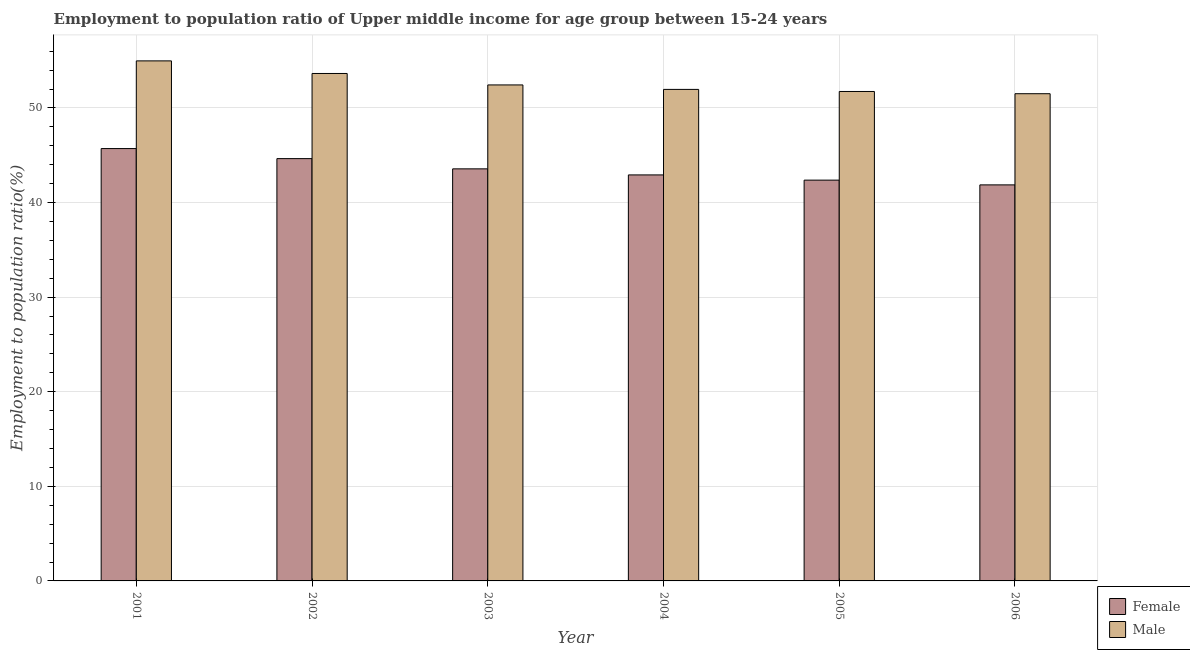How many different coloured bars are there?
Offer a very short reply. 2. Are the number of bars on each tick of the X-axis equal?
Your answer should be very brief. Yes. What is the employment to population ratio(male) in 2005?
Keep it short and to the point. 51.74. Across all years, what is the maximum employment to population ratio(male)?
Your answer should be very brief. 54.98. Across all years, what is the minimum employment to population ratio(female)?
Make the answer very short. 41.87. In which year was the employment to population ratio(male) maximum?
Make the answer very short. 2001. In which year was the employment to population ratio(male) minimum?
Your response must be concise. 2006. What is the total employment to population ratio(male) in the graph?
Provide a short and direct response. 316.27. What is the difference between the employment to population ratio(female) in 2003 and that in 2005?
Offer a terse response. 1.19. What is the difference between the employment to population ratio(male) in 2005 and the employment to population ratio(female) in 2001?
Keep it short and to the point. -3.24. What is the average employment to population ratio(male) per year?
Give a very brief answer. 52.71. What is the ratio of the employment to population ratio(male) in 2002 to that in 2005?
Provide a succinct answer. 1.04. What is the difference between the highest and the second highest employment to population ratio(female)?
Your answer should be very brief. 1.06. What is the difference between the highest and the lowest employment to population ratio(male)?
Provide a short and direct response. 3.47. What does the 1st bar from the right in 2005 represents?
Offer a terse response. Male. How many bars are there?
Offer a very short reply. 12. Are all the bars in the graph horizontal?
Keep it short and to the point. No. How many years are there in the graph?
Your answer should be very brief. 6. What is the difference between two consecutive major ticks on the Y-axis?
Your response must be concise. 10. Does the graph contain grids?
Your response must be concise. Yes. Where does the legend appear in the graph?
Your answer should be compact. Bottom right. How many legend labels are there?
Provide a short and direct response. 2. What is the title of the graph?
Provide a short and direct response. Employment to population ratio of Upper middle income for age group between 15-24 years. What is the label or title of the X-axis?
Provide a succinct answer. Year. What is the label or title of the Y-axis?
Provide a short and direct response. Employment to population ratio(%). What is the Employment to population ratio(%) in Female in 2001?
Keep it short and to the point. 45.71. What is the Employment to population ratio(%) of Male in 2001?
Give a very brief answer. 54.98. What is the Employment to population ratio(%) of Female in 2002?
Your response must be concise. 44.65. What is the Employment to population ratio(%) of Male in 2002?
Keep it short and to the point. 53.65. What is the Employment to population ratio(%) of Female in 2003?
Provide a succinct answer. 43.56. What is the Employment to population ratio(%) of Male in 2003?
Keep it short and to the point. 52.43. What is the Employment to population ratio(%) of Female in 2004?
Your response must be concise. 42.92. What is the Employment to population ratio(%) of Male in 2004?
Provide a succinct answer. 51.96. What is the Employment to population ratio(%) in Female in 2005?
Your answer should be very brief. 42.37. What is the Employment to population ratio(%) in Male in 2005?
Ensure brevity in your answer.  51.74. What is the Employment to population ratio(%) of Female in 2006?
Offer a very short reply. 41.87. What is the Employment to population ratio(%) in Male in 2006?
Provide a succinct answer. 51.51. Across all years, what is the maximum Employment to population ratio(%) in Female?
Your answer should be compact. 45.71. Across all years, what is the maximum Employment to population ratio(%) of Male?
Keep it short and to the point. 54.98. Across all years, what is the minimum Employment to population ratio(%) of Female?
Offer a terse response. 41.87. Across all years, what is the minimum Employment to population ratio(%) in Male?
Make the answer very short. 51.51. What is the total Employment to population ratio(%) in Female in the graph?
Make the answer very short. 261.08. What is the total Employment to population ratio(%) in Male in the graph?
Ensure brevity in your answer.  316.27. What is the difference between the Employment to population ratio(%) in Female in 2001 and that in 2002?
Your answer should be very brief. 1.06. What is the difference between the Employment to population ratio(%) in Male in 2001 and that in 2002?
Make the answer very short. 1.33. What is the difference between the Employment to population ratio(%) of Female in 2001 and that in 2003?
Your answer should be compact. 2.14. What is the difference between the Employment to population ratio(%) of Male in 2001 and that in 2003?
Keep it short and to the point. 2.54. What is the difference between the Employment to population ratio(%) in Female in 2001 and that in 2004?
Ensure brevity in your answer.  2.78. What is the difference between the Employment to population ratio(%) of Male in 2001 and that in 2004?
Give a very brief answer. 3.01. What is the difference between the Employment to population ratio(%) in Female in 2001 and that in 2005?
Offer a terse response. 3.34. What is the difference between the Employment to population ratio(%) in Male in 2001 and that in 2005?
Ensure brevity in your answer.  3.24. What is the difference between the Employment to population ratio(%) of Female in 2001 and that in 2006?
Keep it short and to the point. 3.84. What is the difference between the Employment to population ratio(%) of Male in 2001 and that in 2006?
Keep it short and to the point. 3.47. What is the difference between the Employment to population ratio(%) in Female in 2002 and that in 2003?
Your answer should be very brief. 1.08. What is the difference between the Employment to population ratio(%) of Male in 2002 and that in 2003?
Offer a terse response. 1.21. What is the difference between the Employment to population ratio(%) in Female in 2002 and that in 2004?
Keep it short and to the point. 1.72. What is the difference between the Employment to population ratio(%) in Male in 2002 and that in 2004?
Keep it short and to the point. 1.68. What is the difference between the Employment to population ratio(%) of Female in 2002 and that in 2005?
Ensure brevity in your answer.  2.27. What is the difference between the Employment to population ratio(%) in Male in 2002 and that in 2005?
Your answer should be very brief. 1.9. What is the difference between the Employment to population ratio(%) in Female in 2002 and that in 2006?
Make the answer very short. 2.78. What is the difference between the Employment to population ratio(%) of Male in 2002 and that in 2006?
Offer a very short reply. 2.14. What is the difference between the Employment to population ratio(%) of Female in 2003 and that in 2004?
Provide a short and direct response. 0.64. What is the difference between the Employment to population ratio(%) in Male in 2003 and that in 2004?
Provide a succinct answer. 0.47. What is the difference between the Employment to population ratio(%) of Female in 2003 and that in 2005?
Provide a short and direct response. 1.19. What is the difference between the Employment to population ratio(%) of Male in 2003 and that in 2005?
Your answer should be very brief. 0.69. What is the difference between the Employment to population ratio(%) of Female in 2003 and that in 2006?
Ensure brevity in your answer.  1.69. What is the difference between the Employment to population ratio(%) in Male in 2003 and that in 2006?
Provide a short and direct response. 0.93. What is the difference between the Employment to population ratio(%) of Female in 2004 and that in 2005?
Your answer should be compact. 0.55. What is the difference between the Employment to population ratio(%) in Male in 2004 and that in 2005?
Keep it short and to the point. 0.22. What is the difference between the Employment to population ratio(%) in Female in 2004 and that in 2006?
Ensure brevity in your answer.  1.05. What is the difference between the Employment to population ratio(%) of Male in 2004 and that in 2006?
Ensure brevity in your answer.  0.46. What is the difference between the Employment to population ratio(%) of Female in 2005 and that in 2006?
Provide a succinct answer. 0.5. What is the difference between the Employment to population ratio(%) of Male in 2005 and that in 2006?
Ensure brevity in your answer.  0.24. What is the difference between the Employment to population ratio(%) in Female in 2001 and the Employment to population ratio(%) in Male in 2002?
Give a very brief answer. -7.94. What is the difference between the Employment to population ratio(%) of Female in 2001 and the Employment to population ratio(%) of Male in 2003?
Provide a succinct answer. -6.73. What is the difference between the Employment to population ratio(%) in Female in 2001 and the Employment to population ratio(%) in Male in 2004?
Offer a terse response. -6.26. What is the difference between the Employment to population ratio(%) in Female in 2001 and the Employment to population ratio(%) in Male in 2005?
Provide a succinct answer. -6.03. What is the difference between the Employment to population ratio(%) in Female in 2001 and the Employment to population ratio(%) in Male in 2006?
Your response must be concise. -5.8. What is the difference between the Employment to population ratio(%) in Female in 2002 and the Employment to population ratio(%) in Male in 2003?
Your answer should be very brief. -7.79. What is the difference between the Employment to population ratio(%) of Female in 2002 and the Employment to population ratio(%) of Male in 2004?
Your answer should be very brief. -7.32. What is the difference between the Employment to population ratio(%) in Female in 2002 and the Employment to population ratio(%) in Male in 2005?
Offer a terse response. -7.1. What is the difference between the Employment to population ratio(%) in Female in 2002 and the Employment to population ratio(%) in Male in 2006?
Offer a terse response. -6.86. What is the difference between the Employment to population ratio(%) in Female in 2003 and the Employment to population ratio(%) in Male in 2004?
Your response must be concise. -8.4. What is the difference between the Employment to population ratio(%) in Female in 2003 and the Employment to population ratio(%) in Male in 2005?
Keep it short and to the point. -8.18. What is the difference between the Employment to population ratio(%) of Female in 2003 and the Employment to population ratio(%) of Male in 2006?
Your answer should be compact. -7.94. What is the difference between the Employment to population ratio(%) in Female in 2004 and the Employment to population ratio(%) in Male in 2005?
Your answer should be very brief. -8.82. What is the difference between the Employment to population ratio(%) in Female in 2004 and the Employment to population ratio(%) in Male in 2006?
Your answer should be compact. -8.58. What is the difference between the Employment to population ratio(%) of Female in 2005 and the Employment to population ratio(%) of Male in 2006?
Keep it short and to the point. -9.14. What is the average Employment to population ratio(%) in Female per year?
Offer a very short reply. 43.51. What is the average Employment to population ratio(%) of Male per year?
Your response must be concise. 52.71. In the year 2001, what is the difference between the Employment to population ratio(%) in Female and Employment to population ratio(%) in Male?
Your answer should be very brief. -9.27. In the year 2002, what is the difference between the Employment to population ratio(%) in Female and Employment to population ratio(%) in Male?
Your answer should be compact. -9. In the year 2003, what is the difference between the Employment to population ratio(%) in Female and Employment to population ratio(%) in Male?
Provide a short and direct response. -8.87. In the year 2004, what is the difference between the Employment to population ratio(%) of Female and Employment to population ratio(%) of Male?
Ensure brevity in your answer.  -9.04. In the year 2005, what is the difference between the Employment to population ratio(%) of Female and Employment to population ratio(%) of Male?
Offer a very short reply. -9.37. In the year 2006, what is the difference between the Employment to population ratio(%) of Female and Employment to population ratio(%) of Male?
Make the answer very short. -9.64. What is the ratio of the Employment to population ratio(%) of Female in 2001 to that in 2002?
Your response must be concise. 1.02. What is the ratio of the Employment to population ratio(%) of Male in 2001 to that in 2002?
Your answer should be very brief. 1.02. What is the ratio of the Employment to population ratio(%) in Female in 2001 to that in 2003?
Your answer should be compact. 1.05. What is the ratio of the Employment to population ratio(%) in Male in 2001 to that in 2003?
Your response must be concise. 1.05. What is the ratio of the Employment to population ratio(%) of Female in 2001 to that in 2004?
Keep it short and to the point. 1.06. What is the ratio of the Employment to population ratio(%) of Male in 2001 to that in 2004?
Provide a short and direct response. 1.06. What is the ratio of the Employment to population ratio(%) in Female in 2001 to that in 2005?
Your response must be concise. 1.08. What is the ratio of the Employment to population ratio(%) of Male in 2001 to that in 2005?
Ensure brevity in your answer.  1.06. What is the ratio of the Employment to population ratio(%) of Female in 2001 to that in 2006?
Offer a very short reply. 1.09. What is the ratio of the Employment to population ratio(%) of Male in 2001 to that in 2006?
Your response must be concise. 1.07. What is the ratio of the Employment to population ratio(%) of Female in 2002 to that in 2003?
Provide a succinct answer. 1.02. What is the ratio of the Employment to population ratio(%) in Male in 2002 to that in 2003?
Keep it short and to the point. 1.02. What is the ratio of the Employment to population ratio(%) of Female in 2002 to that in 2004?
Your answer should be very brief. 1.04. What is the ratio of the Employment to population ratio(%) in Male in 2002 to that in 2004?
Ensure brevity in your answer.  1.03. What is the ratio of the Employment to population ratio(%) of Female in 2002 to that in 2005?
Provide a succinct answer. 1.05. What is the ratio of the Employment to population ratio(%) in Male in 2002 to that in 2005?
Provide a succinct answer. 1.04. What is the ratio of the Employment to population ratio(%) of Female in 2002 to that in 2006?
Provide a short and direct response. 1.07. What is the ratio of the Employment to population ratio(%) in Male in 2002 to that in 2006?
Make the answer very short. 1.04. What is the ratio of the Employment to population ratio(%) of Female in 2003 to that in 2004?
Make the answer very short. 1.01. What is the ratio of the Employment to population ratio(%) of Male in 2003 to that in 2004?
Provide a succinct answer. 1.01. What is the ratio of the Employment to population ratio(%) of Female in 2003 to that in 2005?
Your response must be concise. 1.03. What is the ratio of the Employment to population ratio(%) of Male in 2003 to that in 2005?
Offer a very short reply. 1.01. What is the ratio of the Employment to population ratio(%) of Female in 2003 to that in 2006?
Ensure brevity in your answer.  1.04. What is the ratio of the Employment to population ratio(%) of Female in 2004 to that in 2005?
Provide a short and direct response. 1.01. What is the ratio of the Employment to population ratio(%) of Male in 2004 to that in 2005?
Give a very brief answer. 1. What is the ratio of the Employment to population ratio(%) of Female in 2004 to that in 2006?
Your answer should be compact. 1.03. What is the ratio of the Employment to population ratio(%) in Male in 2004 to that in 2006?
Your answer should be compact. 1.01. What is the ratio of the Employment to population ratio(%) in Female in 2005 to that in 2006?
Ensure brevity in your answer.  1.01. What is the ratio of the Employment to population ratio(%) in Male in 2005 to that in 2006?
Provide a succinct answer. 1. What is the difference between the highest and the second highest Employment to population ratio(%) of Female?
Your answer should be compact. 1.06. What is the difference between the highest and the second highest Employment to population ratio(%) in Male?
Provide a succinct answer. 1.33. What is the difference between the highest and the lowest Employment to population ratio(%) in Female?
Ensure brevity in your answer.  3.84. What is the difference between the highest and the lowest Employment to population ratio(%) in Male?
Ensure brevity in your answer.  3.47. 